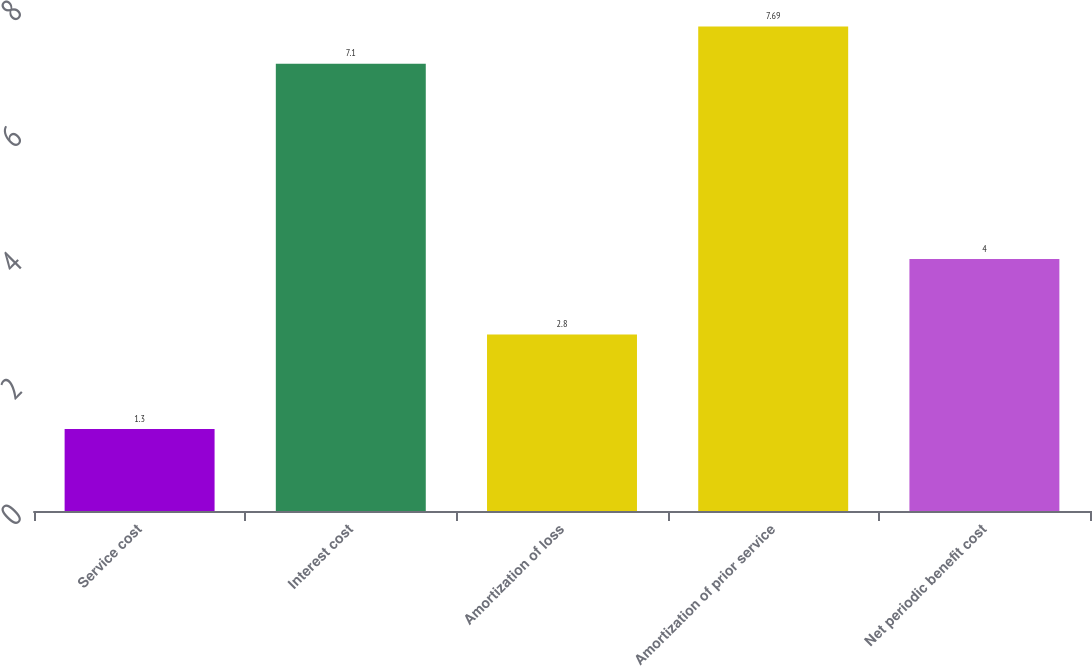<chart> <loc_0><loc_0><loc_500><loc_500><bar_chart><fcel>Service cost<fcel>Interest cost<fcel>Amortization of loss<fcel>Amortization of prior service<fcel>Net periodic benefit cost<nl><fcel>1.3<fcel>7.1<fcel>2.8<fcel>7.69<fcel>4<nl></chart> 